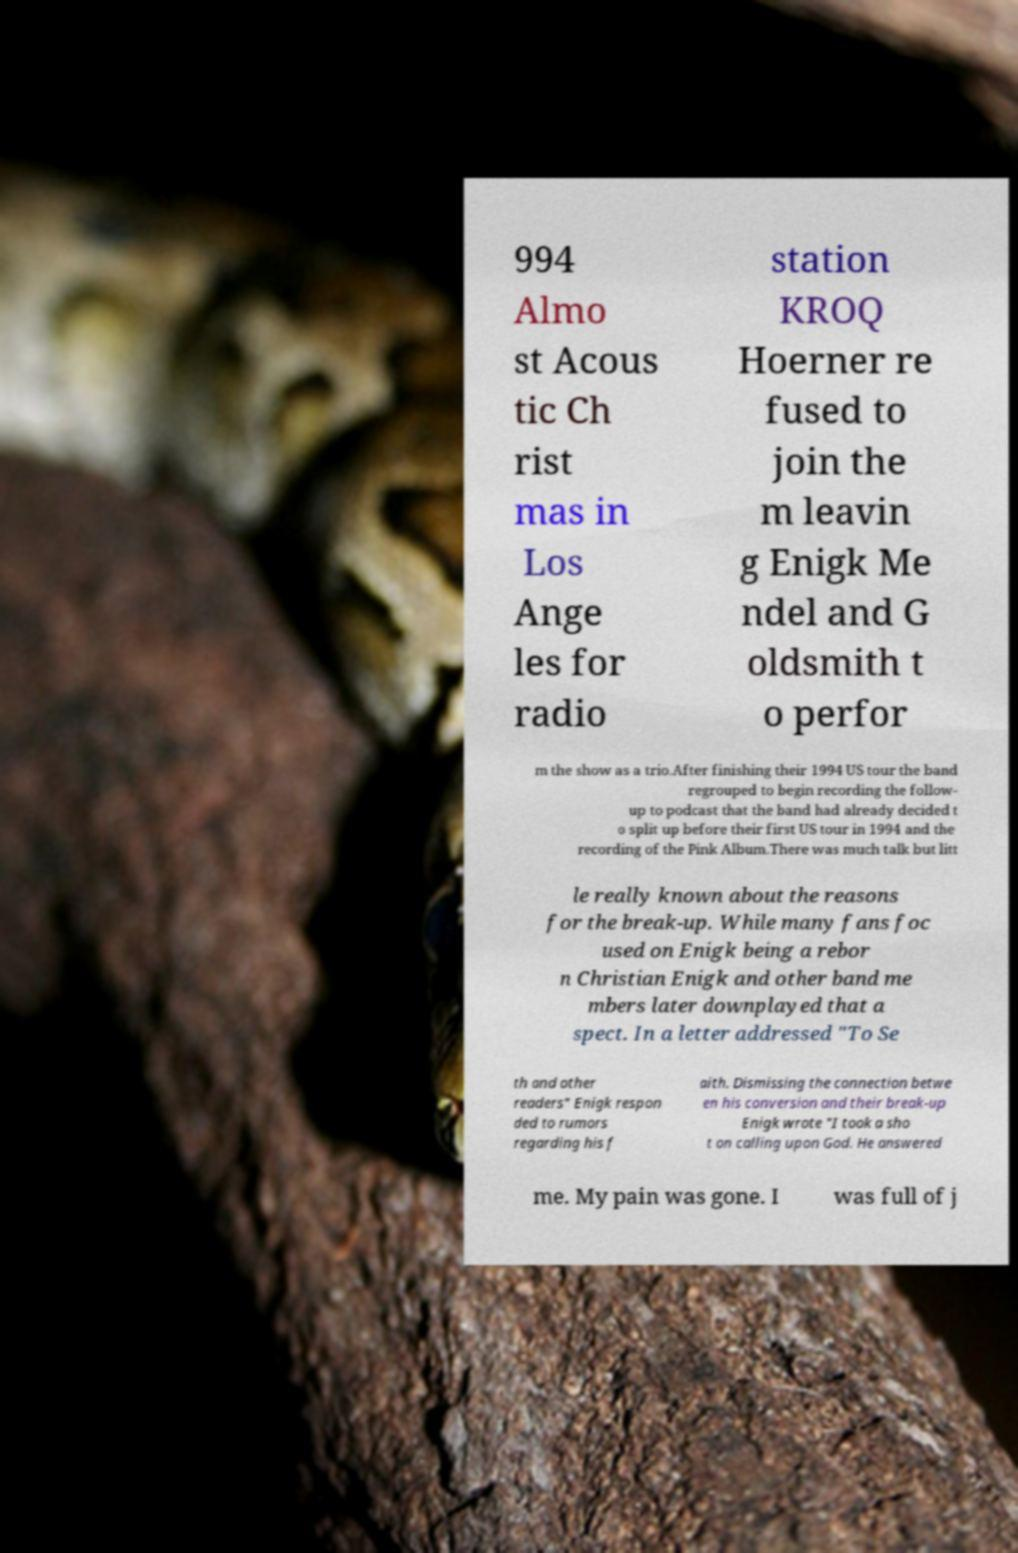For documentation purposes, I need the text within this image transcribed. Could you provide that? 994 Almo st Acous tic Ch rist mas in Los Ange les for radio station KROQ Hoerner re fused to join the m leavin g Enigk Me ndel and G oldsmith t o perfor m the show as a trio.After finishing their 1994 US tour the band regrouped to begin recording the follow- up to podcast that the band had already decided t o split up before their first US tour in 1994 and the recording of the Pink Album.There was much talk but litt le really known about the reasons for the break-up. While many fans foc used on Enigk being a rebor n Christian Enigk and other band me mbers later downplayed that a spect. In a letter addressed "To Se th and other readers" Enigk respon ded to rumors regarding his f aith. Dismissing the connection betwe en his conversion and their break-up Enigk wrote "I took a sho t on calling upon God. He answered me. My pain was gone. I was full of j 